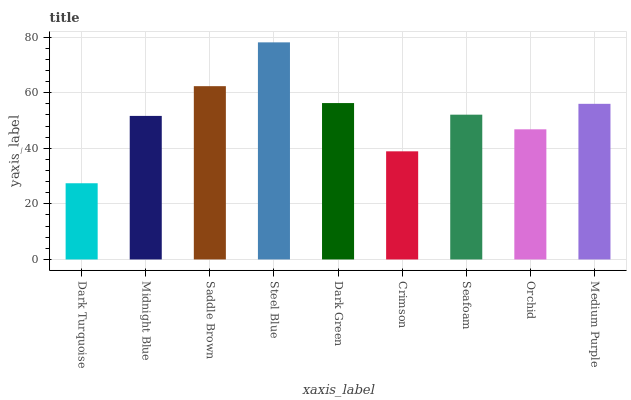Is Midnight Blue the minimum?
Answer yes or no. No. Is Midnight Blue the maximum?
Answer yes or no. No. Is Midnight Blue greater than Dark Turquoise?
Answer yes or no. Yes. Is Dark Turquoise less than Midnight Blue?
Answer yes or no. Yes. Is Dark Turquoise greater than Midnight Blue?
Answer yes or no. No. Is Midnight Blue less than Dark Turquoise?
Answer yes or no. No. Is Seafoam the high median?
Answer yes or no. Yes. Is Seafoam the low median?
Answer yes or no. Yes. Is Orchid the high median?
Answer yes or no. No. Is Dark Green the low median?
Answer yes or no. No. 